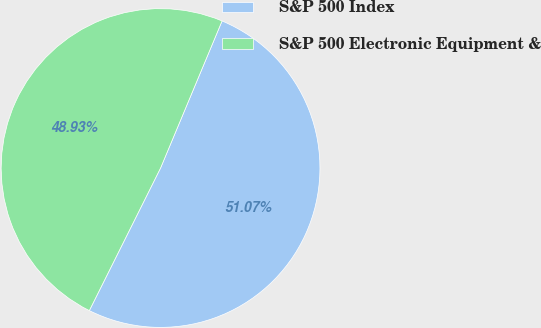Convert chart. <chart><loc_0><loc_0><loc_500><loc_500><pie_chart><fcel>S&P 500 Index<fcel>S&P 500 Electronic Equipment &<nl><fcel>51.07%<fcel>48.93%<nl></chart> 